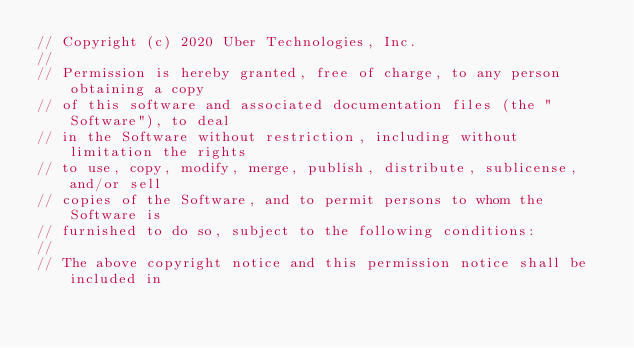Convert code to text. <code><loc_0><loc_0><loc_500><loc_500><_Go_>// Copyright (c) 2020 Uber Technologies, Inc.
//
// Permission is hereby granted, free of charge, to any person obtaining a copy
// of this software and associated documentation files (the "Software"), to deal
// in the Software without restriction, including without limitation the rights
// to use, copy, modify, merge, publish, distribute, sublicense, and/or sell
// copies of the Software, and to permit persons to whom the Software is
// furnished to do so, subject to the following conditions:
//
// The above copyright notice and this permission notice shall be included in</code> 